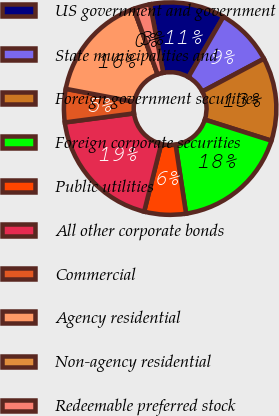Convert chart. <chart><loc_0><loc_0><loc_500><loc_500><pie_chart><fcel>US government and government<fcel>State municipalities and<fcel>Foreign government securities<fcel>Foreign corporate securities<fcel>Public utilities<fcel>All other corporate bonds<fcel>Commercial<fcel>Agency residential<fcel>Non-agency residential<fcel>Redeemable preferred stock<nl><fcel>11.39%<fcel>8.86%<fcel>12.66%<fcel>17.72%<fcel>6.33%<fcel>18.99%<fcel>5.06%<fcel>16.46%<fcel>0.0%<fcel>2.53%<nl></chart> 